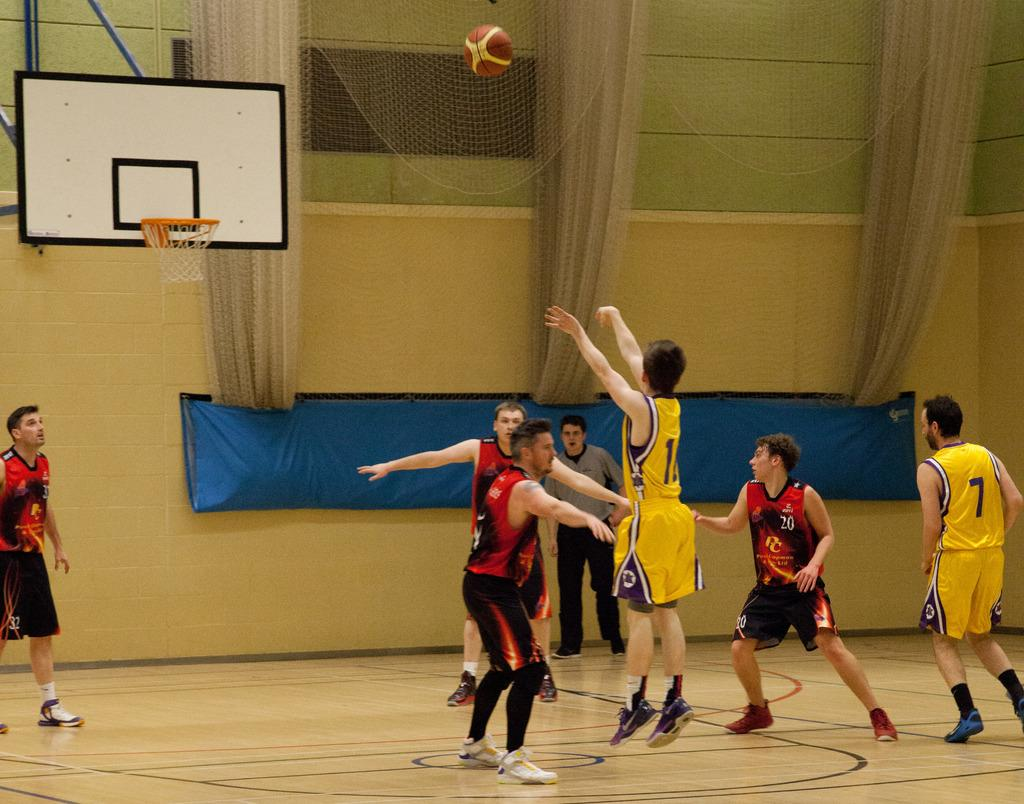Provide a one-sentence caption for the provided image. a group of young men playing basketball with number 11 from the yellow team attempting a shot. 